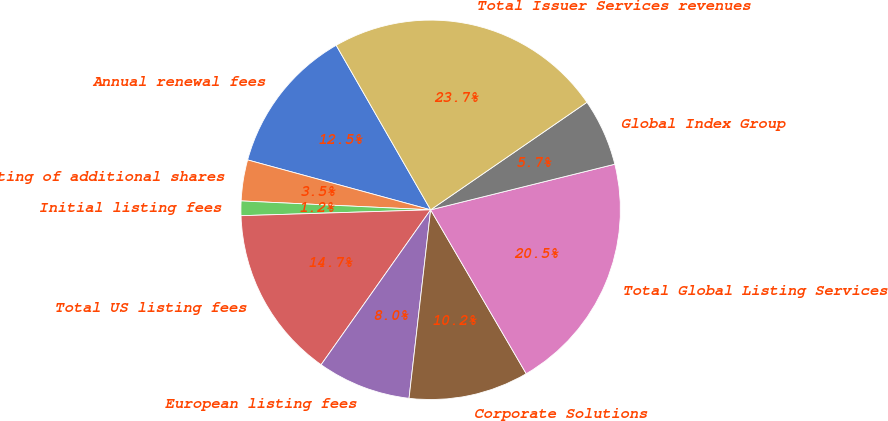Convert chart. <chart><loc_0><loc_0><loc_500><loc_500><pie_chart><fcel>Annual renewal fees<fcel>Listing of additional shares<fcel>Initial listing fees<fcel>Total US listing fees<fcel>European listing fees<fcel>Corporate Solutions<fcel>Total Global Listing Services<fcel>Global Index Group<fcel>Total Issuer Services revenues<nl><fcel>12.47%<fcel>3.49%<fcel>1.24%<fcel>14.71%<fcel>7.98%<fcel>10.22%<fcel>20.46%<fcel>5.73%<fcel>23.7%<nl></chart> 